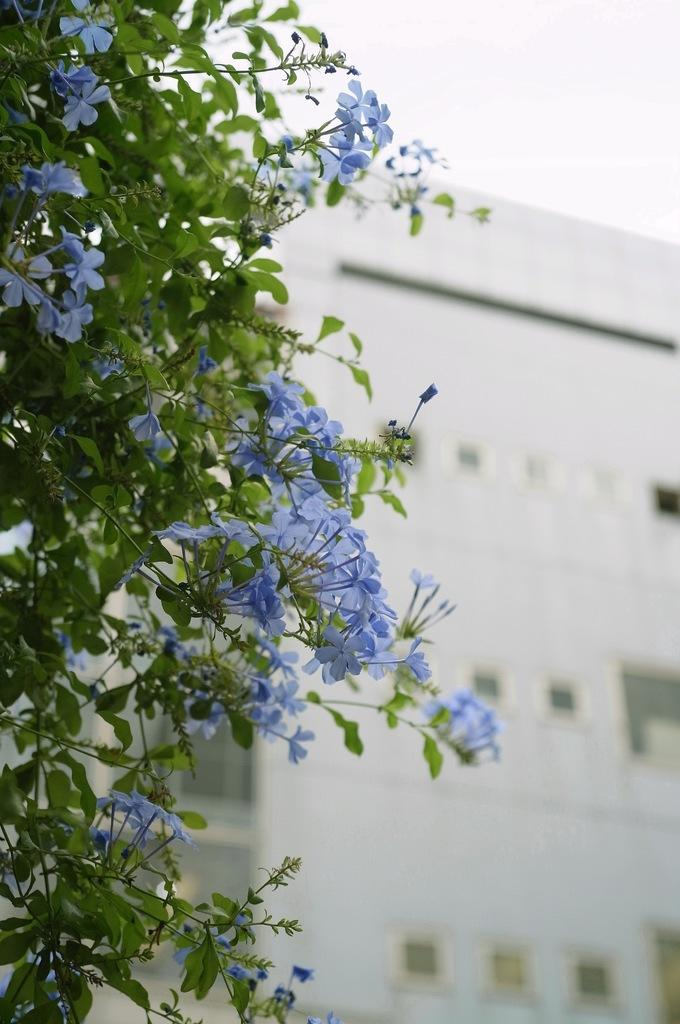What type of plant is present in the image? There is a tree with flowers in the image. What is located behind the tree in the image? There is a building behind the tree. What part of the natural environment is visible in the image? The sky is visible in the image. What type of bells can be heard ringing in the image? There are no bells present in the image, and therefore no sound can be heard. 